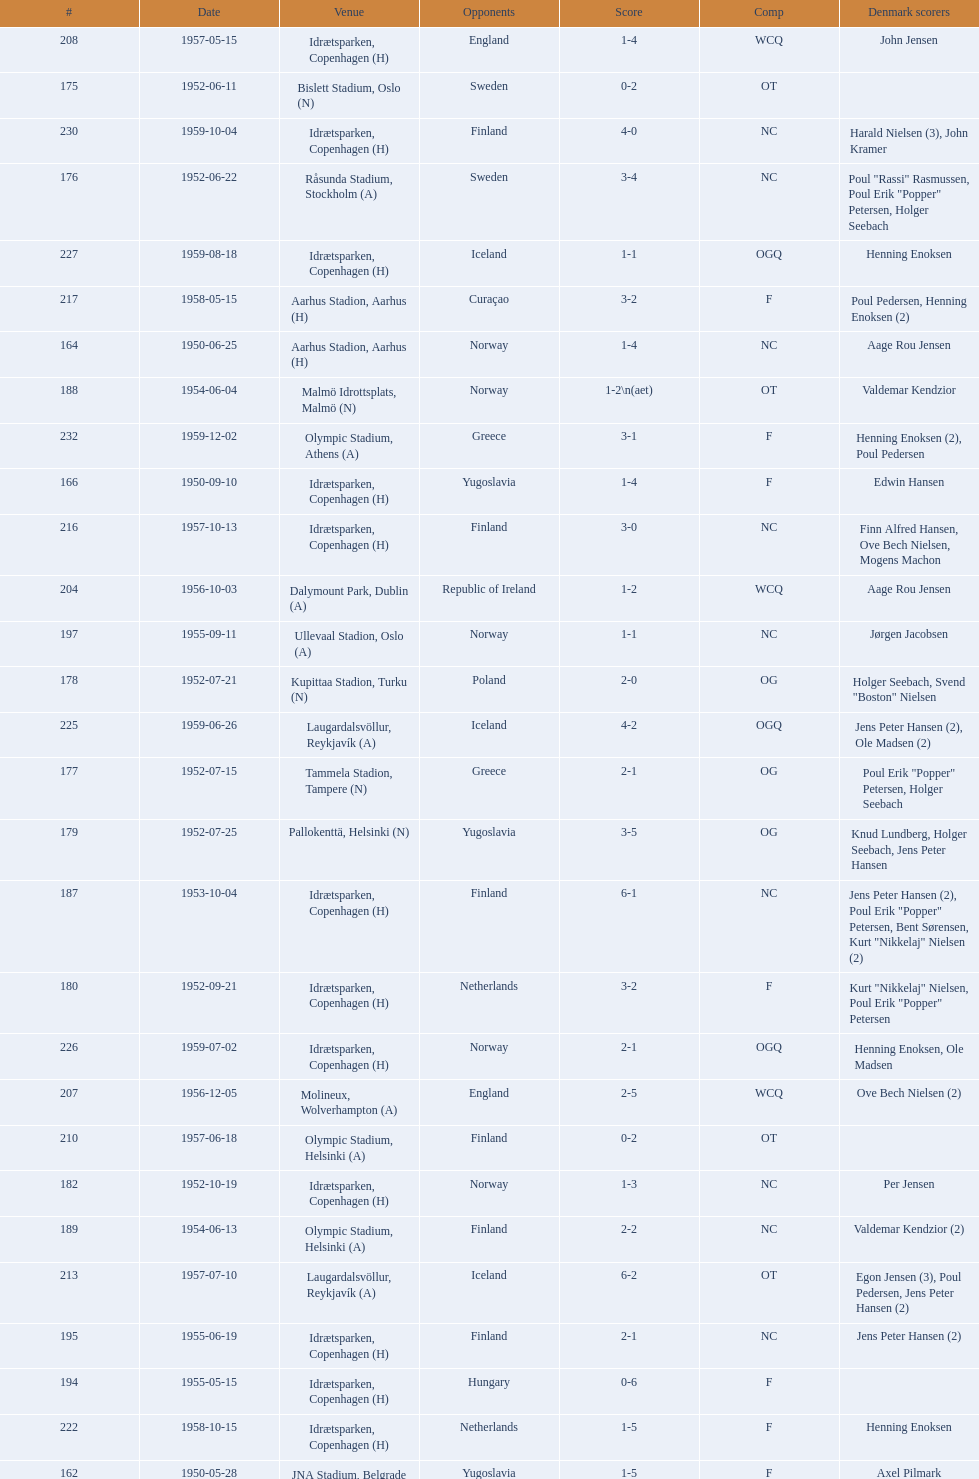What is the name of the venue listed before olympic stadium on 1950-08-27? Aarhus Stadion, Aarhus. 